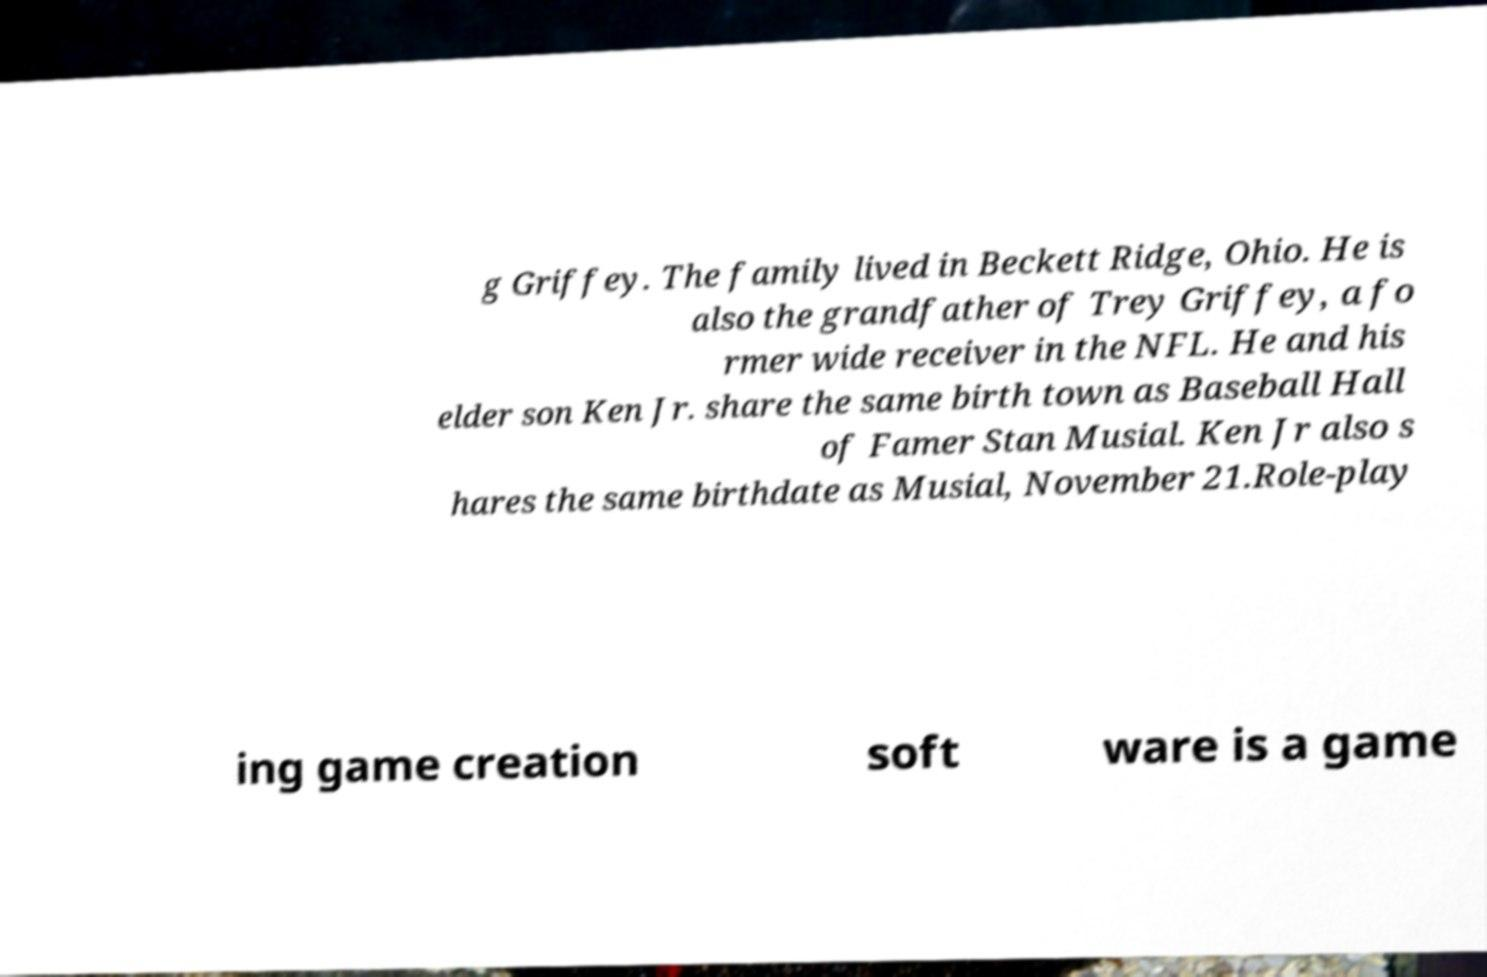Please identify and transcribe the text found in this image. g Griffey. The family lived in Beckett Ridge, Ohio. He is also the grandfather of Trey Griffey, a fo rmer wide receiver in the NFL. He and his elder son Ken Jr. share the same birth town as Baseball Hall of Famer Stan Musial. Ken Jr also s hares the same birthdate as Musial, November 21.Role-play ing game creation soft ware is a game 